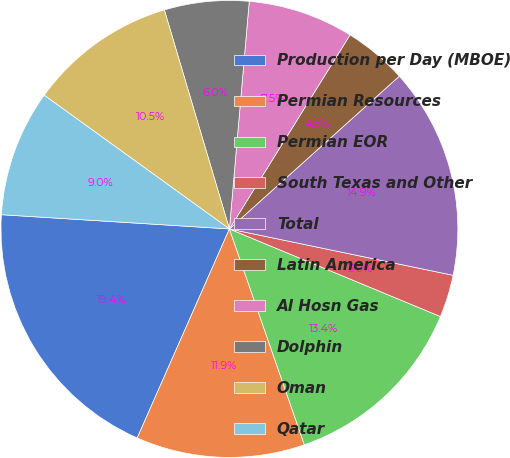Convert chart to OTSL. <chart><loc_0><loc_0><loc_500><loc_500><pie_chart><fcel>Production per Day (MBOE)<fcel>Permian Resources<fcel>Permian EOR<fcel>South Texas and Other<fcel>Total<fcel>Latin America<fcel>Al Hosn Gas<fcel>Dolphin<fcel>Oman<fcel>Qatar<nl><fcel>19.38%<fcel>11.93%<fcel>13.42%<fcel>3.01%<fcel>14.91%<fcel>4.49%<fcel>7.47%<fcel>5.98%<fcel>10.45%<fcel>8.96%<nl></chart> 